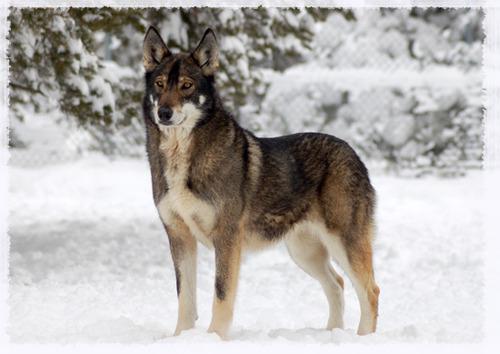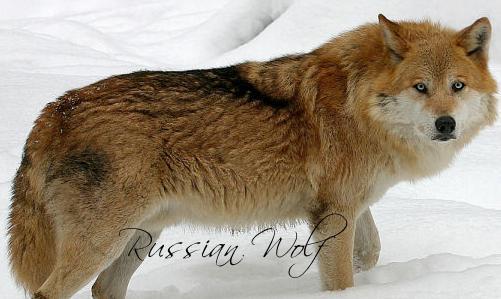The first image is the image on the left, the second image is the image on the right. Examine the images to the left and right. Is the description "An image shows two adult huskies reclining side-by-side in the snow, with a dusting of snow on their fur." accurate? Answer yes or no. No. The first image is the image on the left, the second image is the image on the right. For the images shown, is this caption "There is one dog who is not in the snow." true? Answer yes or no. No. 